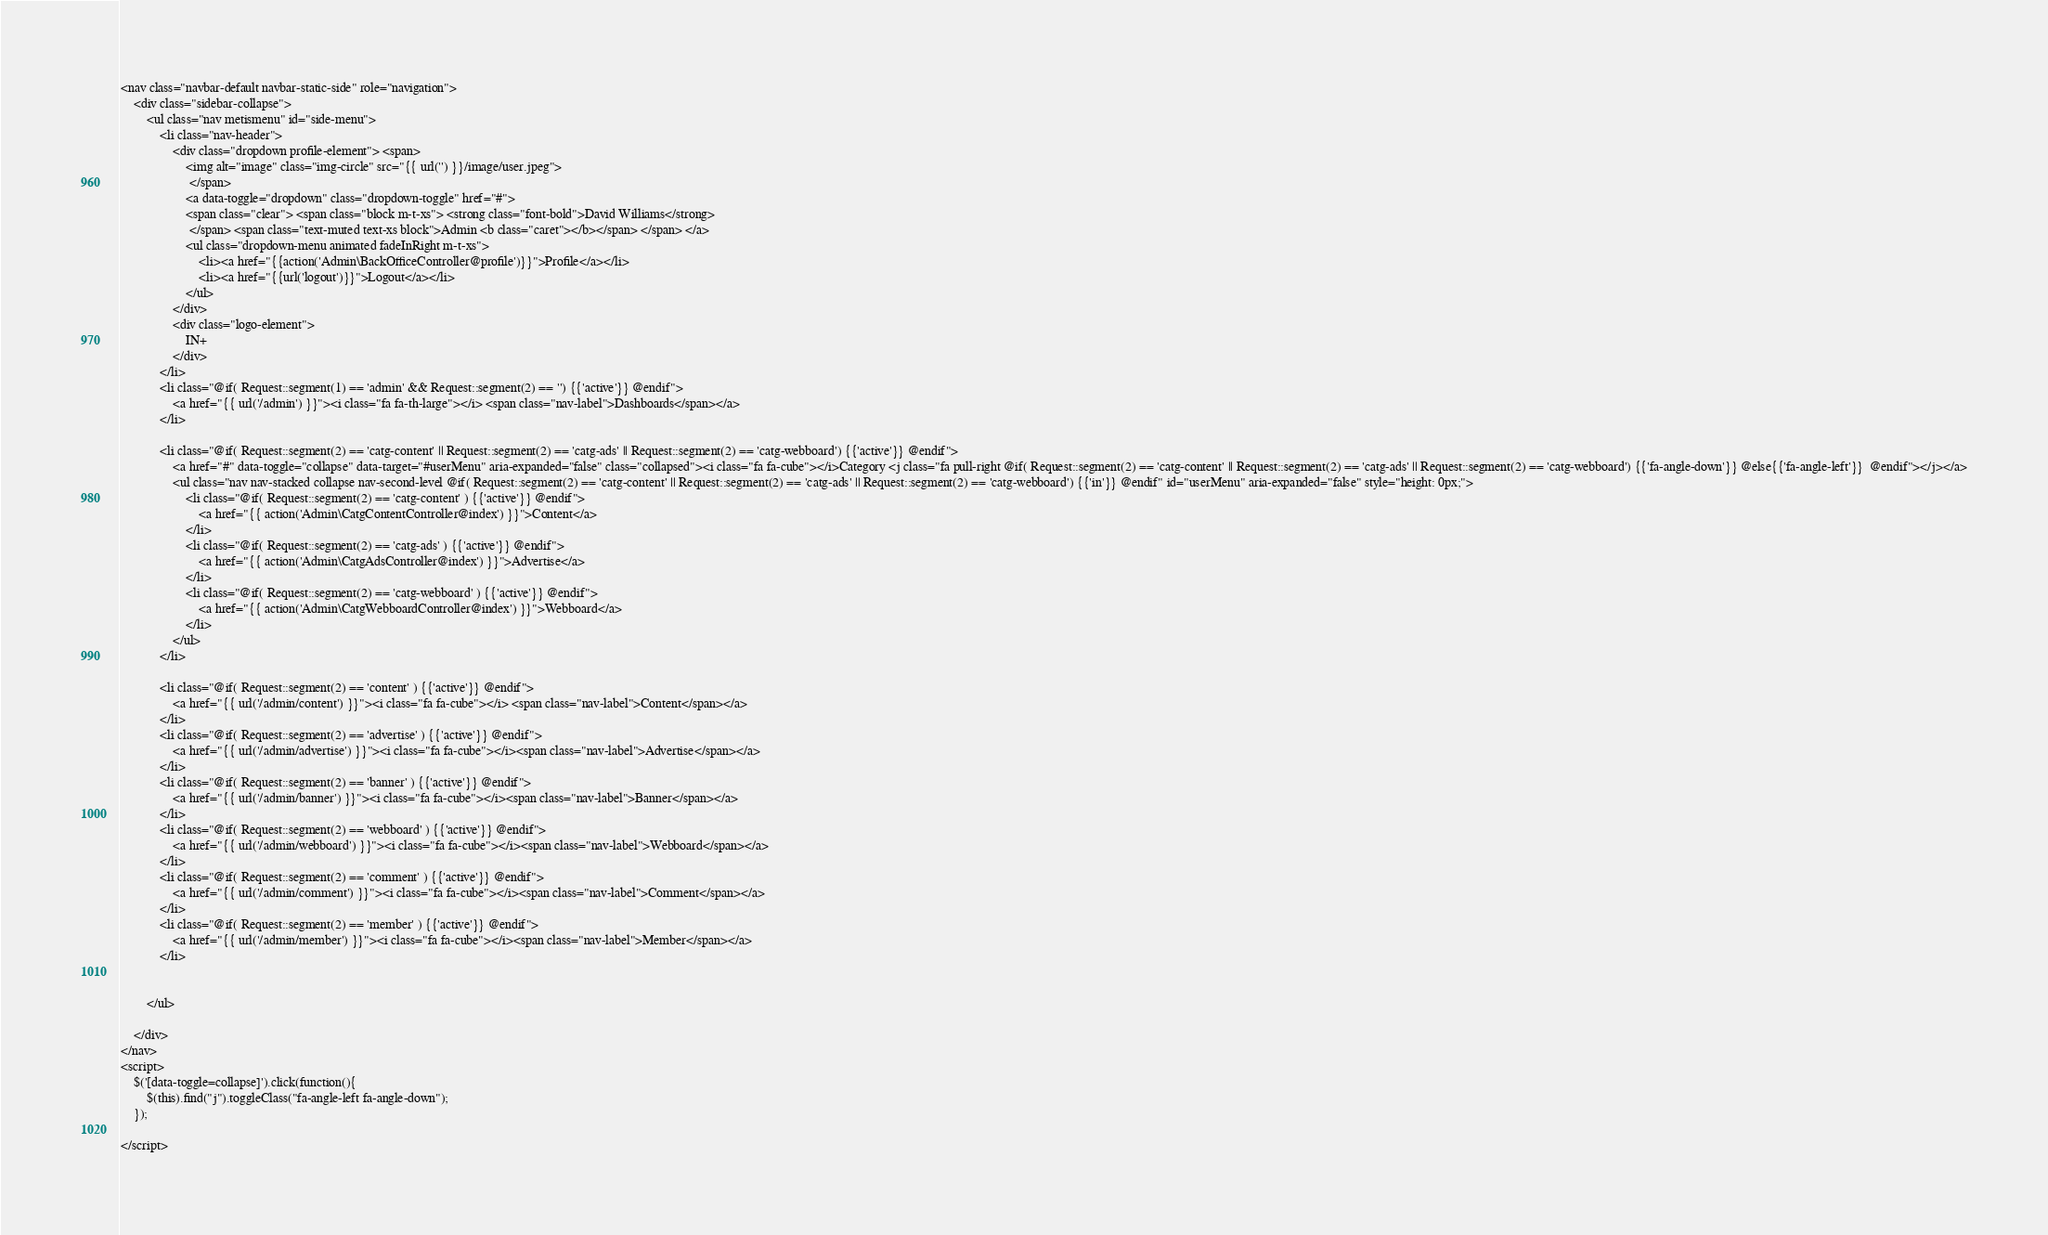<code> <loc_0><loc_0><loc_500><loc_500><_PHP_><nav class="navbar-default navbar-static-side" role="navigation">
    <div class="sidebar-collapse">
        <ul class="nav metismenu" id="side-menu">
            <li class="nav-header">
                <div class="dropdown profile-element"> <span>
                    <img alt="image" class="img-circle" src="{{ url('') }}/image/user.jpeg">
                     </span>
                    <a data-toggle="dropdown" class="dropdown-toggle" href="#">
                    <span class="clear"> <span class="block m-t-xs"> <strong class="font-bold">David Williams</strong>
                     </span> <span class="text-muted text-xs block">Admin <b class="caret"></b></span> </span> </a>
                    <ul class="dropdown-menu animated fadeInRight m-t-xs">
                        <li><a href="{{action('Admin\BackOfficeController@profile')}}">Profile</a></li>
                        <li><a href="{{url('logout')}}">Logout</a></li>
                    </ul>
                </div>
                <div class="logo-element">
                    IN+
                </div>
            </li>
            <li class="@if( Request::segment(1) == 'admin' && Request::segment(2) == '') {{'active'}} @endif">
                <a href="{{ url('/admin') }}"><i class="fa fa-th-large"></i> <span class="nav-label">Dashboards</span></a>
            </li>

            <li class="@if( Request::segment(2) == 'catg-content' || Request::segment(2) == 'catg-ads' || Request::segment(2) == 'catg-webboard') {{'active'}} @endif"> 
                <a href="#" data-toggle="collapse" data-target="#userMenu" aria-expanded="false" class="collapsed"><i class="fa fa-cube"></i>Category <j class="fa pull-right @if( Request::segment(2) == 'catg-content' || Request::segment(2) == 'catg-ads' || Request::segment(2) == 'catg-webboard') {{'fa-angle-down'}} @else{{'fa-angle-left'}}  @endif"></j></a>
                <ul class="nav nav-stacked collapse nav-second-level @if( Request::segment(2) == 'catg-content' || Request::segment(2) == 'catg-ads' || Request::segment(2) == 'catg-webboard') {{'in'}} @endif" id="userMenu" aria-expanded="false" style="height: 0px;">
                    <li class="@if( Request::segment(2) == 'catg-content' ) {{'active'}} @endif">
                        <a href="{{ action('Admin\CatgContentController@index') }}">Content</a>
                    </li>
                    <li class="@if( Request::segment(2) == 'catg-ads' ) {{'active'}} @endif">
                        <a href="{{ action('Admin\CatgAdsController@index') }}">Advertise</a>
                    </li>
                    <li class="@if( Request::segment(2) == 'catg-webboard' ) {{'active'}} @endif">
                        <a href="{{ action('Admin\CatgWebboardController@index') }}">Webboard</a>
                    </li>
                </ul>
            </li>

            <li class="@if( Request::segment(2) == 'content' ) {{'active'}} @endif">
                <a href="{{ url('/admin/content') }}"><i class="fa fa-cube"></i> <span class="nav-label">Content</span></a>
            </li>
            <li class="@if( Request::segment(2) == 'advertise' ) {{'active'}} @endif">
                <a href="{{ url('/admin/advertise') }}"><i class="fa fa-cube"></i><span class="nav-label">Advertise</span></a>
            </li>
            <li class="@if( Request::segment(2) == 'banner' ) {{'active'}} @endif">
                <a href="{{ url('/admin/banner') }}"><i class="fa fa-cube"></i><span class="nav-label">Banner</span></a>
            </li>
            <li class="@if( Request::segment(2) == 'webboard' ) {{'active'}} @endif">
                <a href="{{ url('/admin/webboard') }}"><i class="fa fa-cube"></i><span class="nav-label">Webboard</span></a>
            </li>
            <li class="@if( Request::segment(2) == 'comment' ) {{'active'}} @endif">
                <a href="{{ url('/admin/comment') }}"><i class="fa fa-cube"></i><span class="nav-label">Comment</span></a>
            </li>
            <li class="@if( Request::segment(2) == 'member' ) {{'active'}} @endif">
                <a href="{{ url('/admin/member') }}"><i class="fa fa-cube"></i><span class="nav-label">Member</span></a>
            </li>
            

        </ul>

    </div>
</nav>
<script>
    $('[data-toggle=collapse]').click(function(){
        $(this).find("j").toggleClass("fa-angle-left fa-angle-down");
    });

</script>
</code> 